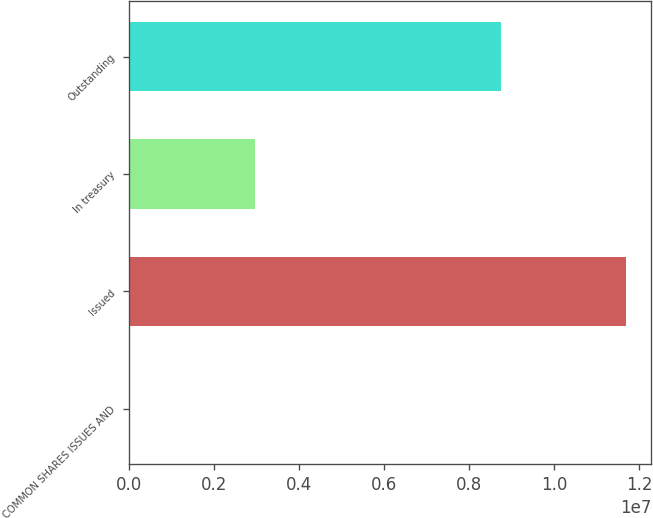<chart> <loc_0><loc_0><loc_500><loc_500><bar_chart><fcel>COMMON SHARES ISSUES AND<fcel>Issued<fcel>In treasury<fcel>Outstanding<nl><fcel>2016<fcel>1.16938e+07<fcel>2.95123e+06<fcel>8.74261e+06<nl></chart> 